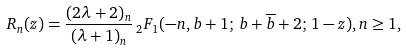Convert formula to latex. <formula><loc_0><loc_0><loc_500><loc_500>R _ { n } ( z ) = \frac { ( 2 \lambda + 2 ) _ { n } } { ( \lambda + 1 ) _ { n } } \, _ { 2 } F _ { 1 } ( - n , b + 1 ; \, b + \overline { b } + 2 ; \, 1 - z ) , n \geq 1 ,</formula> 